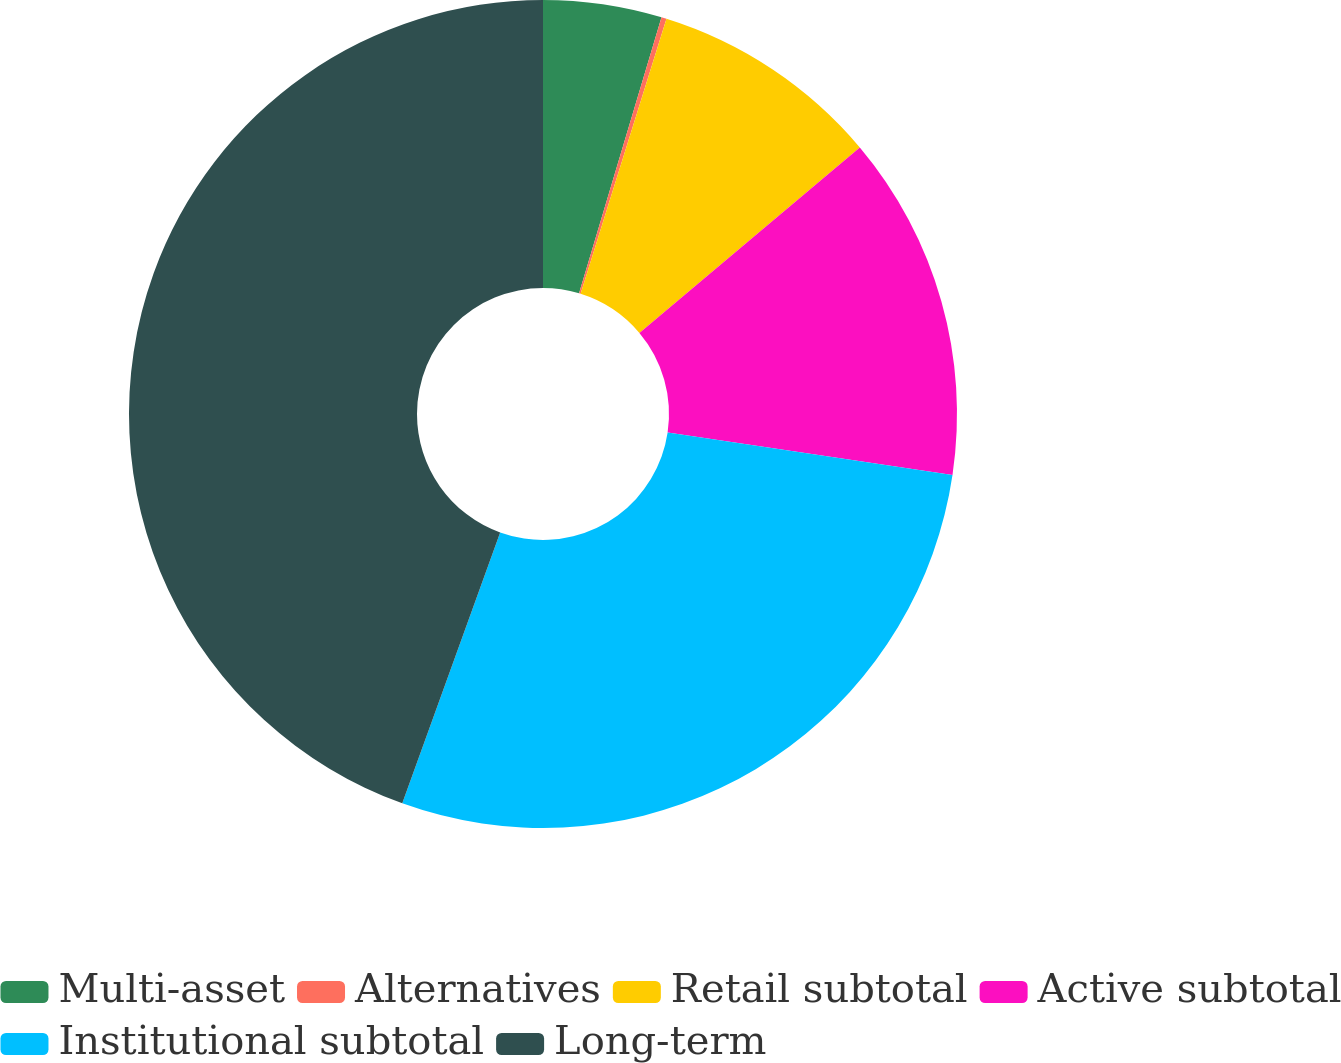Convert chart. <chart><loc_0><loc_0><loc_500><loc_500><pie_chart><fcel>Multi-asset<fcel>Alternatives<fcel>Retail subtotal<fcel>Active subtotal<fcel>Institutional subtotal<fcel>Long-term<nl><fcel>4.62%<fcel>0.2%<fcel>9.05%<fcel>13.48%<fcel>28.17%<fcel>44.48%<nl></chart> 